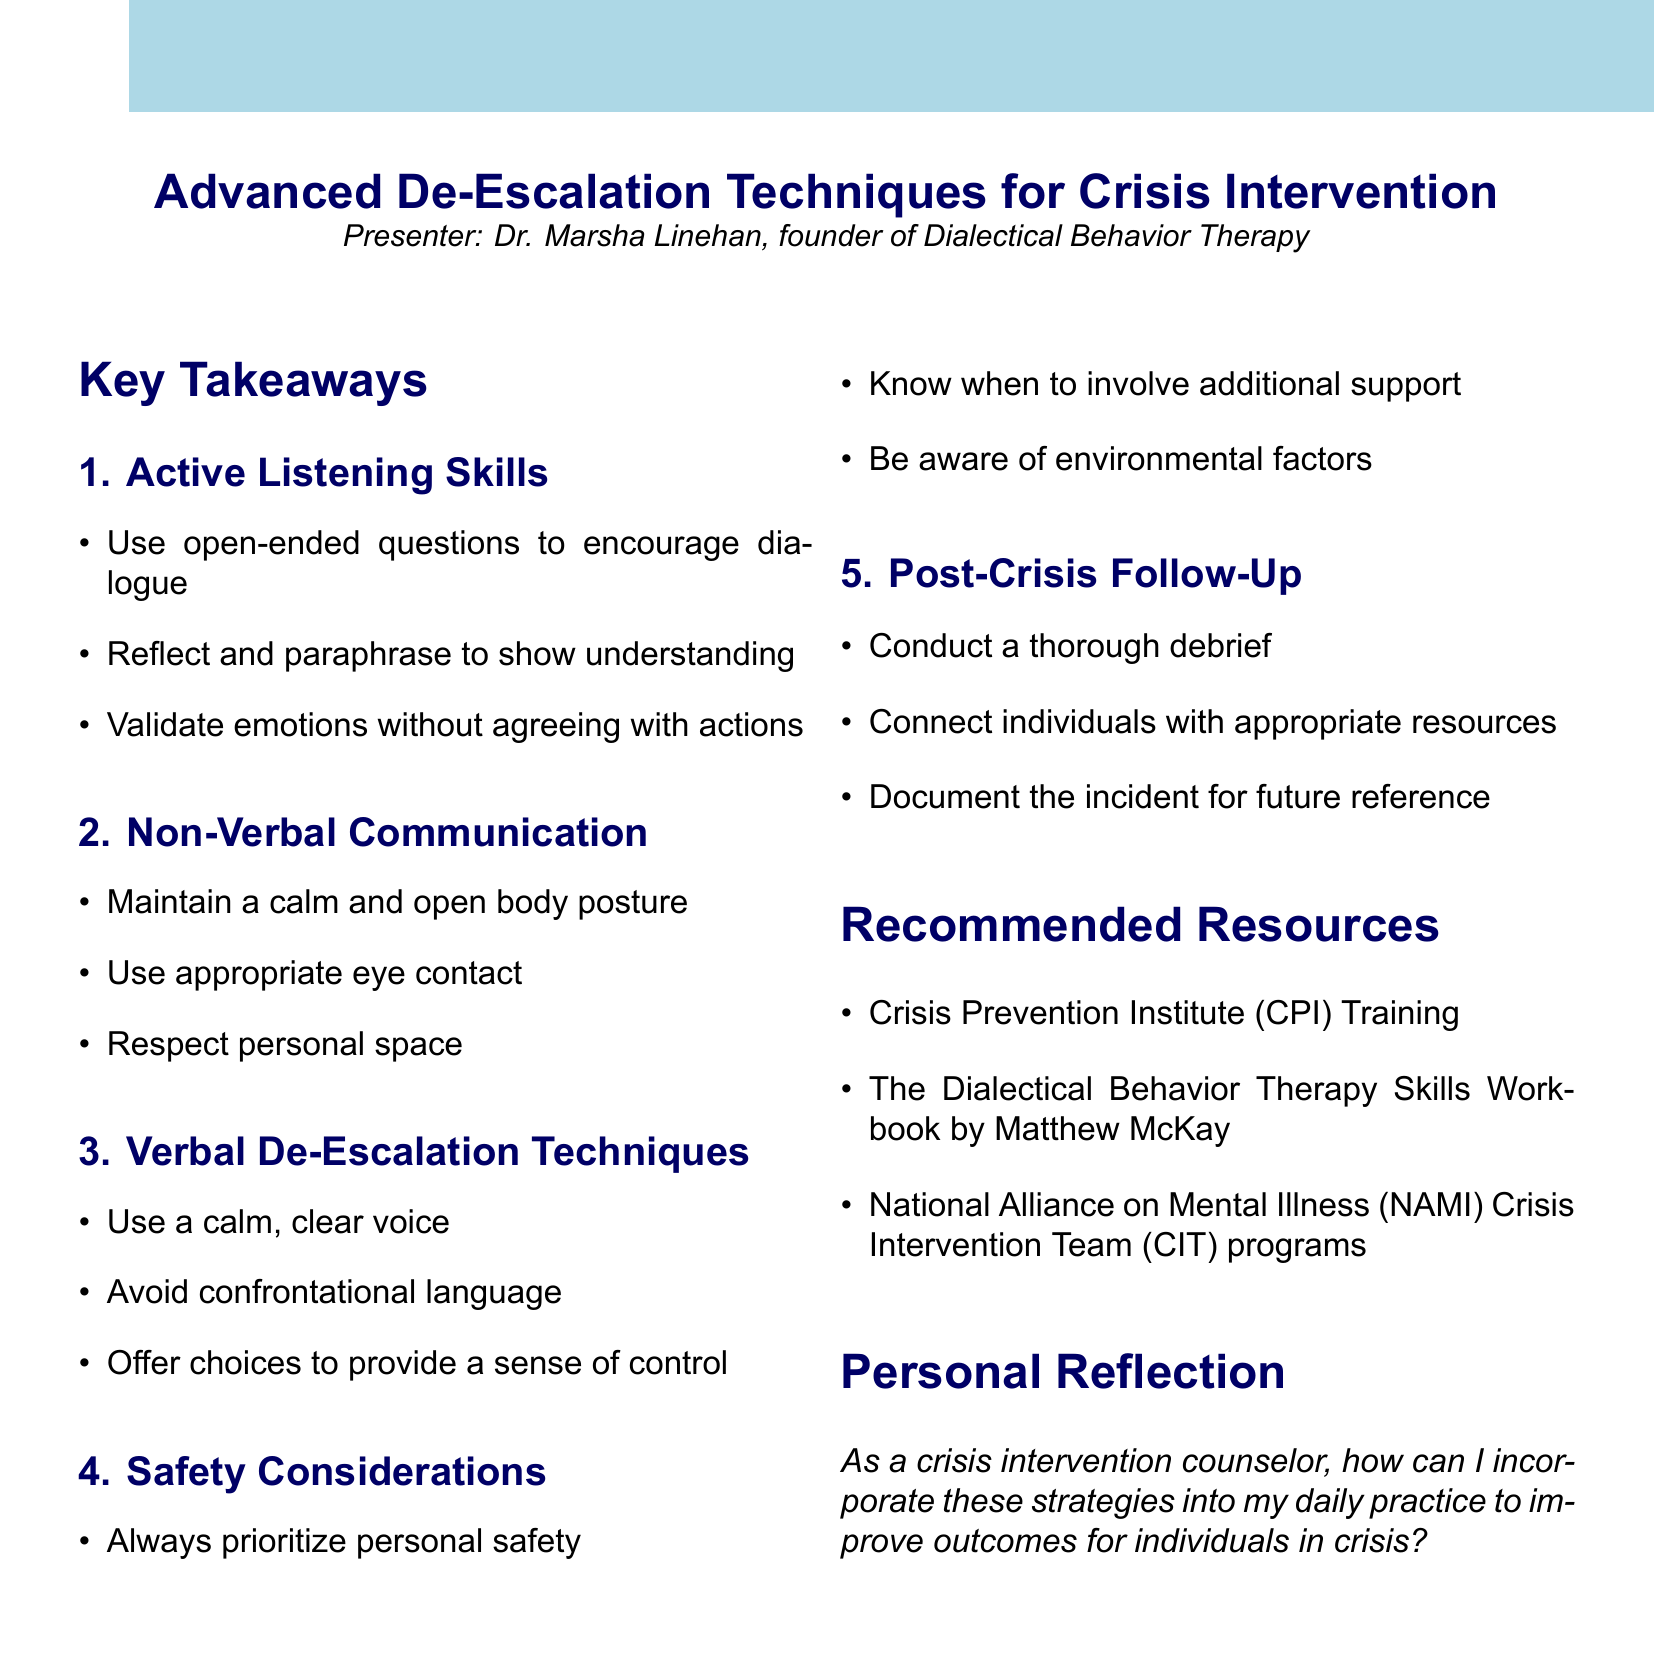What is the title of the workshop? The title of the workshop is listed at the beginning of the document under the workshop_title key.
Answer: Advanced De-Escalation Techniques for Crisis Intervention Who is the presenter of the workshop? The presenter's name is provided right below the workshop title in the document.
Answer: Dr. Marsha Linehan What are the three points of Active Listening Skills? The points are outlined under the key takeaways section specifically for Active Listening Skills.
Answer: Use open-ended questions to encourage dialogue, Reflect and paraphrase to show understanding, Validate emotions without agreeing with actions What should you prioritize according to Safety Considerations? This is specified in the Safety Considerations section and emphasizes the importance of prioritizing safety.
Answer: Always prioritize personal safety What is one method of Verbal De-Escalation Techniques? This can be found under the section discussing Verbal De-Escalation Techniques in the document.
Answer: Use a calm, clear voice What should you do in the Post-Crisis Follow-Up? This is detailed in the Post-Crisis Follow-Up section, which includes actions to take after a crisis.
Answer: Conduct a thorough debrief How many resources are recommended in the document? The number of recommended resources can be counted from the list provided in the document.
Answer: Three What is the focus of the personal reflection? The personal reflection is included in a dedicated section, highlighting the importance of incorporating strategies into practice.
Answer: Incorporate these strategies into my daily practice to improve outcomes for individuals in crisis What type of training is suggested as a resource? A specific type of training is mentioned in the Recommended Resources section of the document.
Answer: Crisis Prevention Institute (CPI) Training 